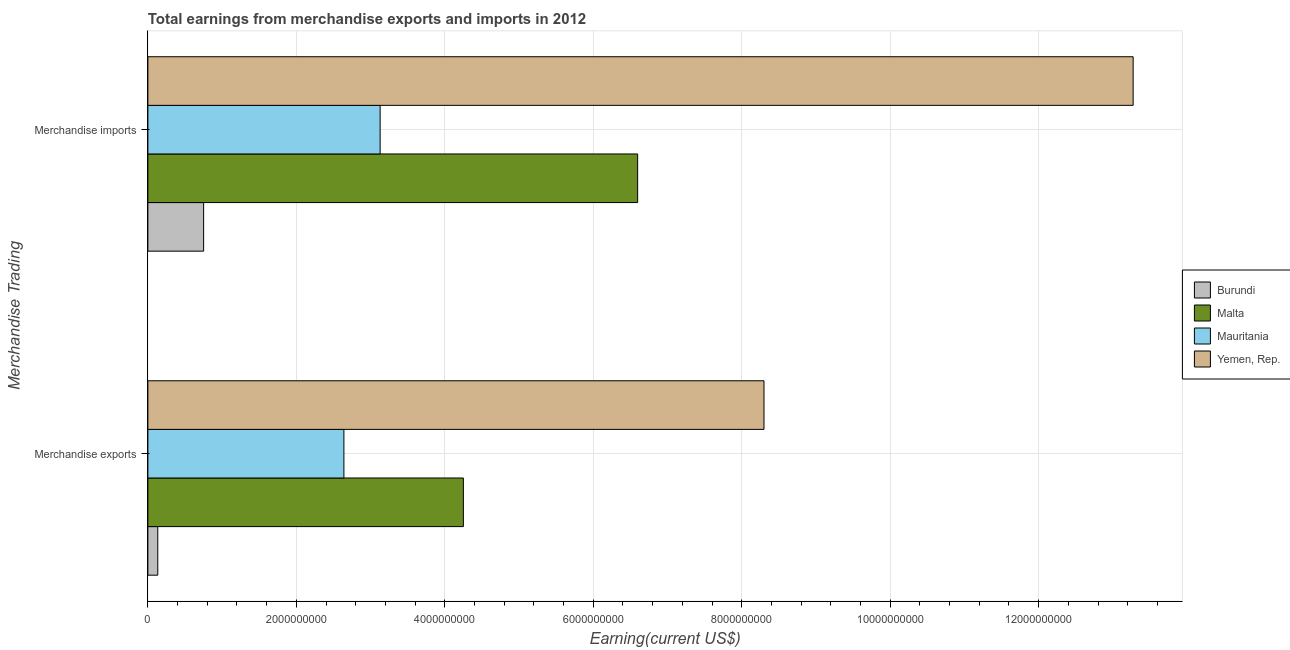How many different coloured bars are there?
Provide a succinct answer. 4. Are the number of bars per tick equal to the number of legend labels?
Your answer should be compact. Yes. What is the earnings from merchandise exports in Yemen, Rep.?
Your response must be concise. 8.30e+09. Across all countries, what is the maximum earnings from merchandise exports?
Keep it short and to the point. 8.30e+09. Across all countries, what is the minimum earnings from merchandise exports?
Your answer should be compact. 1.34e+08. In which country was the earnings from merchandise imports maximum?
Your answer should be very brief. Yemen, Rep. In which country was the earnings from merchandise imports minimum?
Ensure brevity in your answer.  Burundi. What is the total earnings from merchandise imports in the graph?
Ensure brevity in your answer.  2.38e+1. What is the difference between the earnings from merchandise exports in Malta and that in Mauritania?
Your answer should be compact. 1.61e+09. What is the difference between the earnings from merchandise exports in Malta and the earnings from merchandise imports in Burundi?
Provide a succinct answer. 3.50e+09. What is the average earnings from merchandise imports per country?
Offer a very short reply. 5.94e+09. What is the difference between the earnings from merchandise exports and earnings from merchandise imports in Yemen, Rep.?
Make the answer very short. -4.97e+09. In how many countries, is the earnings from merchandise imports greater than 12000000000 US$?
Your answer should be very brief. 1. What is the ratio of the earnings from merchandise imports in Burundi to that in Mauritania?
Make the answer very short. 0.24. Is the earnings from merchandise imports in Yemen, Rep. less than that in Malta?
Offer a terse response. No. What does the 4th bar from the top in Merchandise exports represents?
Make the answer very short. Burundi. What does the 2nd bar from the bottom in Merchandise imports represents?
Your answer should be very brief. Malta. How many bars are there?
Make the answer very short. 8. How many countries are there in the graph?
Offer a terse response. 4. What is the difference between two consecutive major ticks on the X-axis?
Keep it short and to the point. 2.00e+09. Does the graph contain any zero values?
Your response must be concise. No. Does the graph contain grids?
Offer a terse response. Yes. How many legend labels are there?
Offer a very short reply. 4. What is the title of the graph?
Your response must be concise. Total earnings from merchandise exports and imports in 2012. What is the label or title of the X-axis?
Your response must be concise. Earning(current US$). What is the label or title of the Y-axis?
Provide a succinct answer. Merchandise Trading. What is the Earning(current US$) of Burundi in Merchandise exports?
Offer a very short reply. 1.34e+08. What is the Earning(current US$) in Malta in Merchandise exports?
Offer a very short reply. 4.25e+09. What is the Earning(current US$) in Mauritania in Merchandise exports?
Your answer should be compact. 2.64e+09. What is the Earning(current US$) of Yemen, Rep. in Merchandise exports?
Your response must be concise. 8.30e+09. What is the Earning(current US$) in Burundi in Merchandise imports?
Ensure brevity in your answer.  7.51e+08. What is the Earning(current US$) in Malta in Merchandise imports?
Your response must be concise. 6.60e+09. What is the Earning(current US$) of Mauritania in Merchandise imports?
Provide a short and direct response. 3.13e+09. What is the Earning(current US$) of Yemen, Rep. in Merchandise imports?
Provide a short and direct response. 1.33e+1. Across all Merchandise Trading, what is the maximum Earning(current US$) in Burundi?
Give a very brief answer. 7.51e+08. Across all Merchandise Trading, what is the maximum Earning(current US$) of Malta?
Provide a succinct answer. 6.60e+09. Across all Merchandise Trading, what is the maximum Earning(current US$) of Mauritania?
Offer a terse response. 3.13e+09. Across all Merchandise Trading, what is the maximum Earning(current US$) of Yemen, Rep.?
Your answer should be compact. 1.33e+1. Across all Merchandise Trading, what is the minimum Earning(current US$) in Burundi?
Offer a very short reply. 1.34e+08. Across all Merchandise Trading, what is the minimum Earning(current US$) in Malta?
Offer a very short reply. 4.25e+09. Across all Merchandise Trading, what is the minimum Earning(current US$) of Mauritania?
Offer a very short reply. 2.64e+09. Across all Merchandise Trading, what is the minimum Earning(current US$) in Yemen, Rep.?
Ensure brevity in your answer.  8.30e+09. What is the total Earning(current US$) of Burundi in the graph?
Give a very brief answer. 8.85e+08. What is the total Earning(current US$) of Malta in the graph?
Make the answer very short. 1.08e+1. What is the total Earning(current US$) of Mauritania in the graph?
Your answer should be very brief. 5.77e+09. What is the total Earning(current US$) in Yemen, Rep. in the graph?
Provide a succinct answer. 2.16e+1. What is the difference between the Earning(current US$) of Burundi in Merchandise exports and that in Merchandise imports?
Provide a short and direct response. -6.18e+08. What is the difference between the Earning(current US$) of Malta in Merchandise exports and that in Merchandise imports?
Your answer should be very brief. -2.35e+09. What is the difference between the Earning(current US$) of Mauritania in Merchandise exports and that in Merchandise imports?
Keep it short and to the point. -4.88e+08. What is the difference between the Earning(current US$) in Yemen, Rep. in Merchandise exports and that in Merchandise imports?
Give a very brief answer. -4.97e+09. What is the difference between the Earning(current US$) of Burundi in Merchandise exports and the Earning(current US$) of Malta in Merchandise imports?
Give a very brief answer. -6.46e+09. What is the difference between the Earning(current US$) of Burundi in Merchandise exports and the Earning(current US$) of Mauritania in Merchandise imports?
Keep it short and to the point. -3.00e+09. What is the difference between the Earning(current US$) in Burundi in Merchandise exports and the Earning(current US$) in Yemen, Rep. in Merchandise imports?
Offer a very short reply. -1.31e+1. What is the difference between the Earning(current US$) of Malta in Merchandise exports and the Earning(current US$) of Mauritania in Merchandise imports?
Ensure brevity in your answer.  1.12e+09. What is the difference between the Earning(current US$) in Malta in Merchandise exports and the Earning(current US$) in Yemen, Rep. in Merchandise imports?
Give a very brief answer. -9.02e+09. What is the difference between the Earning(current US$) of Mauritania in Merchandise exports and the Earning(current US$) of Yemen, Rep. in Merchandise imports?
Give a very brief answer. -1.06e+1. What is the average Earning(current US$) of Burundi per Merchandise Trading?
Make the answer very short. 4.42e+08. What is the average Earning(current US$) of Malta per Merchandise Trading?
Make the answer very short. 5.42e+09. What is the average Earning(current US$) of Mauritania per Merchandise Trading?
Offer a terse response. 2.88e+09. What is the average Earning(current US$) of Yemen, Rep. per Merchandise Trading?
Your answer should be compact. 1.08e+1. What is the difference between the Earning(current US$) in Burundi and Earning(current US$) in Malta in Merchandise exports?
Make the answer very short. -4.12e+09. What is the difference between the Earning(current US$) in Burundi and Earning(current US$) in Mauritania in Merchandise exports?
Ensure brevity in your answer.  -2.51e+09. What is the difference between the Earning(current US$) in Burundi and Earning(current US$) in Yemen, Rep. in Merchandise exports?
Give a very brief answer. -8.17e+09. What is the difference between the Earning(current US$) in Malta and Earning(current US$) in Mauritania in Merchandise exports?
Your response must be concise. 1.61e+09. What is the difference between the Earning(current US$) in Malta and Earning(current US$) in Yemen, Rep. in Merchandise exports?
Your response must be concise. -4.05e+09. What is the difference between the Earning(current US$) in Mauritania and Earning(current US$) in Yemen, Rep. in Merchandise exports?
Provide a succinct answer. -5.66e+09. What is the difference between the Earning(current US$) of Burundi and Earning(current US$) of Malta in Merchandise imports?
Offer a very short reply. -5.85e+09. What is the difference between the Earning(current US$) in Burundi and Earning(current US$) in Mauritania in Merchandise imports?
Your answer should be compact. -2.38e+09. What is the difference between the Earning(current US$) of Burundi and Earning(current US$) of Yemen, Rep. in Merchandise imports?
Your response must be concise. -1.25e+1. What is the difference between the Earning(current US$) of Malta and Earning(current US$) of Mauritania in Merchandise imports?
Provide a short and direct response. 3.47e+09. What is the difference between the Earning(current US$) of Malta and Earning(current US$) of Yemen, Rep. in Merchandise imports?
Your response must be concise. -6.68e+09. What is the difference between the Earning(current US$) of Mauritania and Earning(current US$) of Yemen, Rep. in Merchandise imports?
Your response must be concise. -1.01e+1. What is the ratio of the Earning(current US$) of Burundi in Merchandise exports to that in Merchandise imports?
Your answer should be very brief. 0.18. What is the ratio of the Earning(current US$) in Malta in Merchandise exports to that in Merchandise imports?
Offer a very short reply. 0.64. What is the ratio of the Earning(current US$) of Mauritania in Merchandise exports to that in Merchandise imports?
Your answer should be very brief. 0.84. What is the ratio of the Earning(current US$) in Yemen, Rep. in Merchandise exports to that in Merchandise imports?
Give a very brief answer. 0.63. What is the difference between the highest and the second highest Earning(current US$) of Burundi?
Ensure brevity in your answer.  6.18e+08. What is the difference between the highest and the second highest Earning(current US$) of Malta?
Provide a short and direct response. 2.35e+09. What is the difference between the highest and the second highest Earning(current US$) of Mauritania?
Offer a very short reply. 4.88e+08. What is the difference between the highest and the second highest Earning(current US$) of Yemen, Rep.?
Provide a succinct answer. 4.97e+09. What is the difference between the highest and the lowest Earning(current US$) of Burundi?
Your answer should be very brief. 6.18e+08. What is the difference between the highest and the lowest Earning(current US$) of Malta?
Provide a short and direct response. 2.35e+09. What is the difference between the highest and the lowest Earning(current US$) of Mauritania?
Ensure brevity in your answer.  4.88e+08. What is the difference between the highest and the lowest Earning(current US$) of Yemen, Rep.?
Make the answer very short. 4.97e+09. 